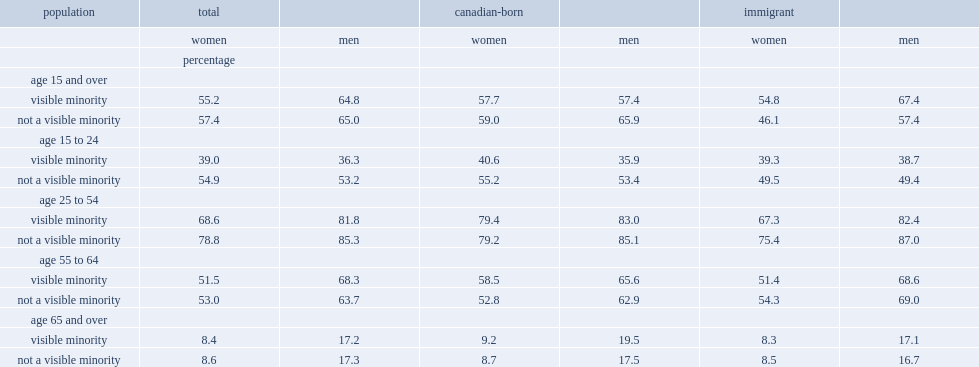What was the percentage of visible minority women were employed in 2010? 55.2. What was the employment rate for the rest of the female population not a visible minority? 57.4. Among visible minority women of core working age, what was the employment rate? 68.6. What was the employment rate among 25 to 54 aged women who were not a visible minority higher than women visible minority? 10.2. When considering only the canadian-born population, what was the employment rate among core working-age women, regardless of visible minority status? 79.2. Among visible minority immigrants of core working age, what was the employment rate lower than that of the canadian-born visible minority population of the same age? 12.1. What was the emplyment rate of immigrant women who did not belong to a visible minority group lower than that of canadian-born women who did not belong to a visible minority group? 3.8. Among people of core working age, what was the employment rate of visible minority women lower than that of visible minority men? 13.2. What was the employment rate of women of core working age who were not a visible minority lower than that of their male counterparts? 6.5. 